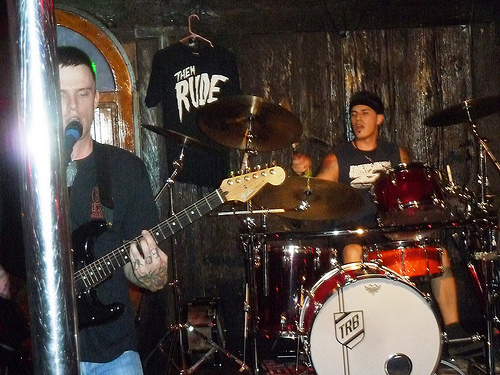<image>
Is there a man on the guitar? Yes. Looking at the image, I can see the man is positioned on top of the guitar, with the guitar providing support. Is the curtain behind the drum? Yes. From this viewpoint, the curtain is positioned behind the drum, with the drum partially or fully occluding the curtain. 